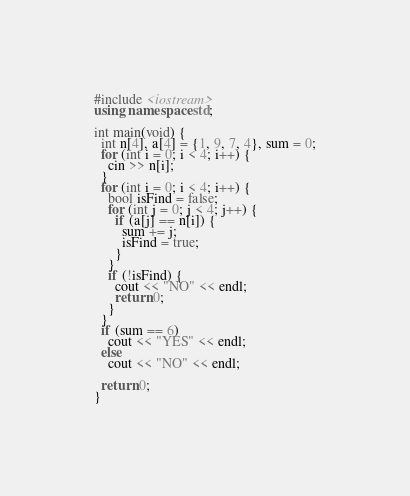Convert code to text. <code><loc_0><loc_0><loc_500><loc_500><_C++_>#include <iostream>
using namespace std;

int main(void) {
  int n[4], a[4] = {1, 9, 7, 4}, sum = 0;
  for (int i = 0; i < 4; i++) {
    cin >> n[i];
  }
  for (int i = 0; i < 4; i++) {
    bool isFind = false;
    for (int j = 0; j < 4; j++) {
      if (a[j] == n[i]) {
        sum += j;
        isFind = true;
      }
    }
    if (!isFind) {
      cout << "NO" << endl;
      return 0;
    }
  }
  if (sum == 6)
    cout << "YES" << endl;
  else
    cout << "NO" << endl;

  return 0;
}
</code> 